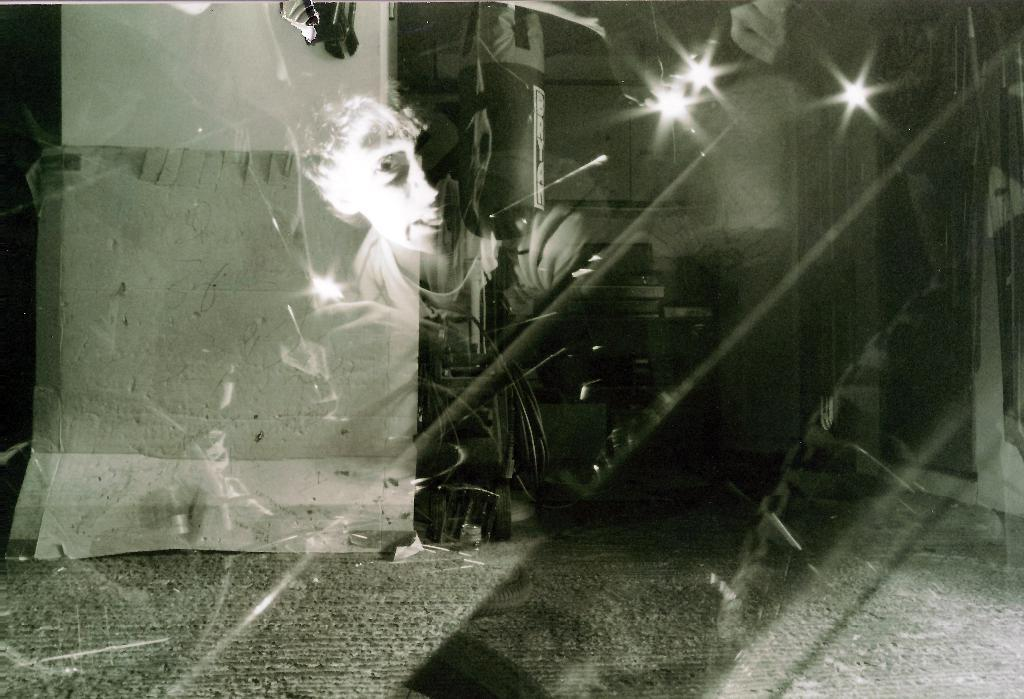What is visible in the image due to reflection? There is a boy's reflection on a glass in the image. What can be seen in the background of the image? There is a cardboard and a wall in the background of the image. Are there any other objects visible in the background? Yes, there are other objects visible in the background of the image. What type of jam is being used for the science experiment in the image? There is no jam or science experiment present in the image. 